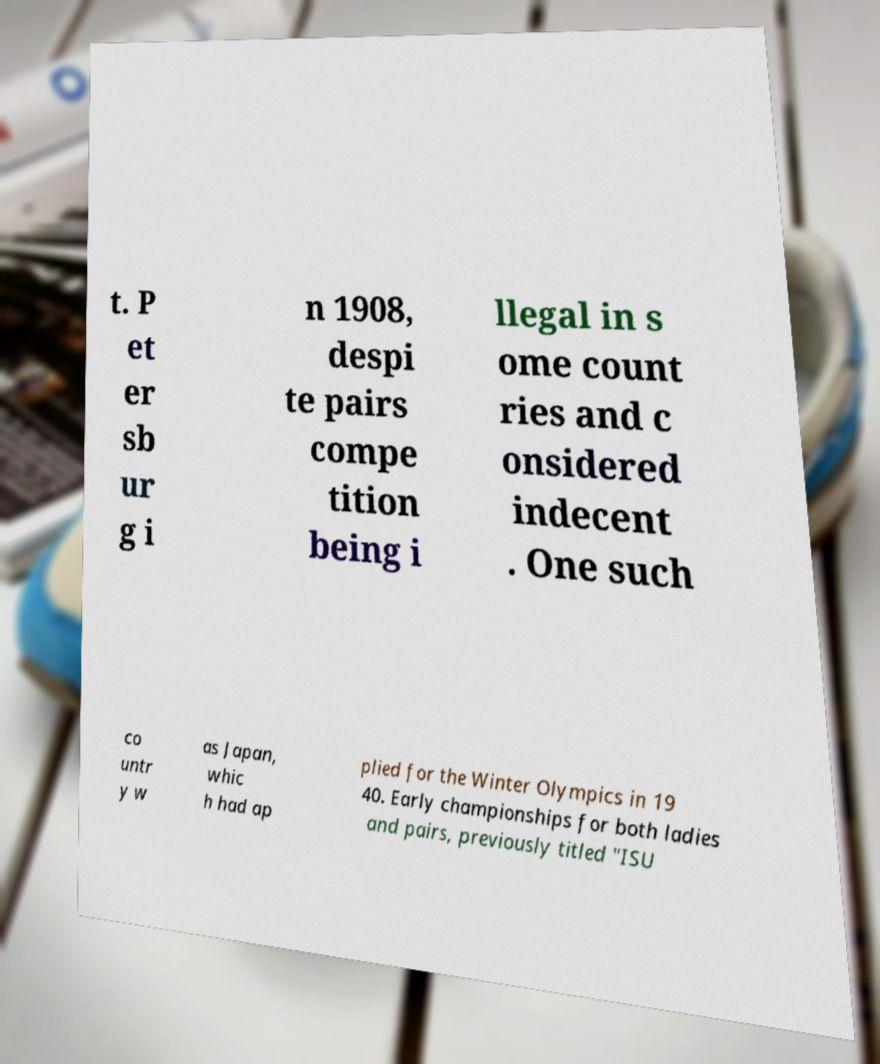Could you extract and type out the text from this image? t. P et er sb ur g i n 1908, despi te pairs compe tition being i llegal in s ome count ries and c onsidered indecent . One such co untr y w as Japan, whic h had ap plied for the Winter Olympics in 19 40. Early championships for both ladies and pairs, previously titled "ISU 